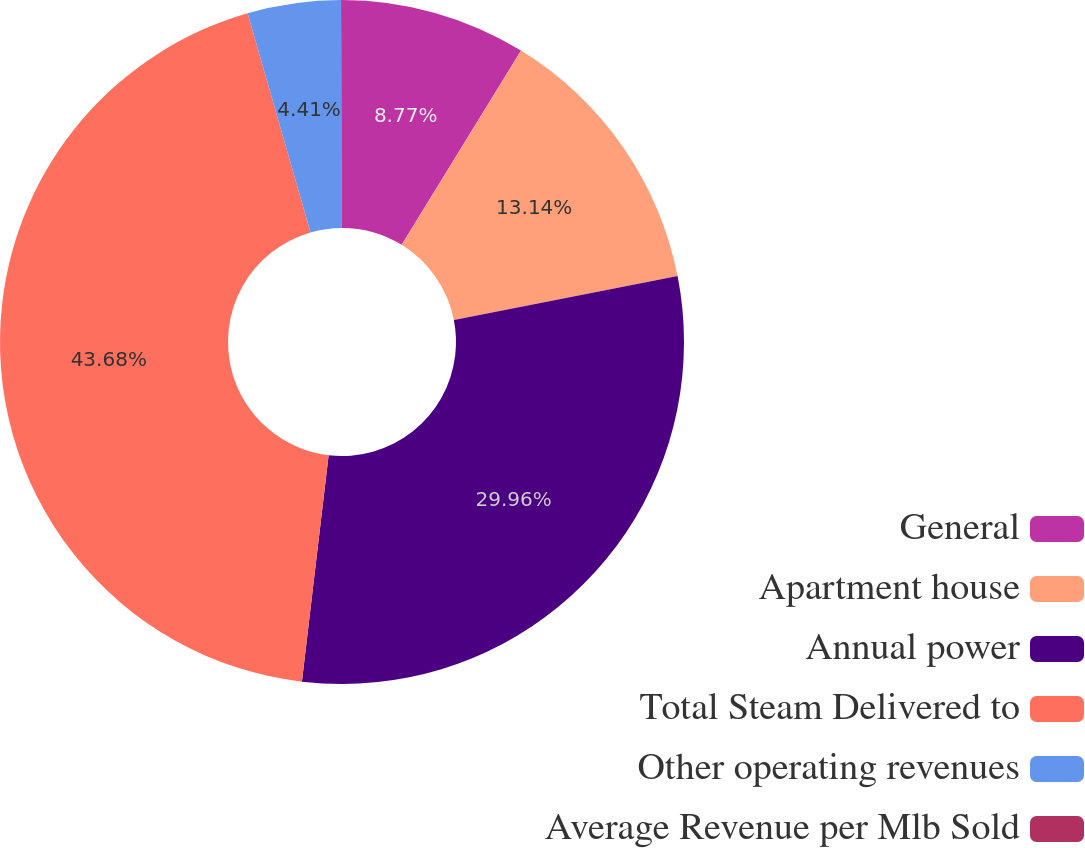Convert chart to OTSL. <chart><loc_0><loc_0><loc_500><loc_500><pie_chart><fcel>General<fcel>Apartment house<fcel>Annual power<fcel>Total Steam Delivered to<fcel>Other operating revenues<fcel>Average Revenue per Mlb Sold<nl><fcel>8.77%<fcel>13.14%<fcel>29.96%<fcel>43.68%<fcel>4.41%<fcel>0.04%<nl></chart> 